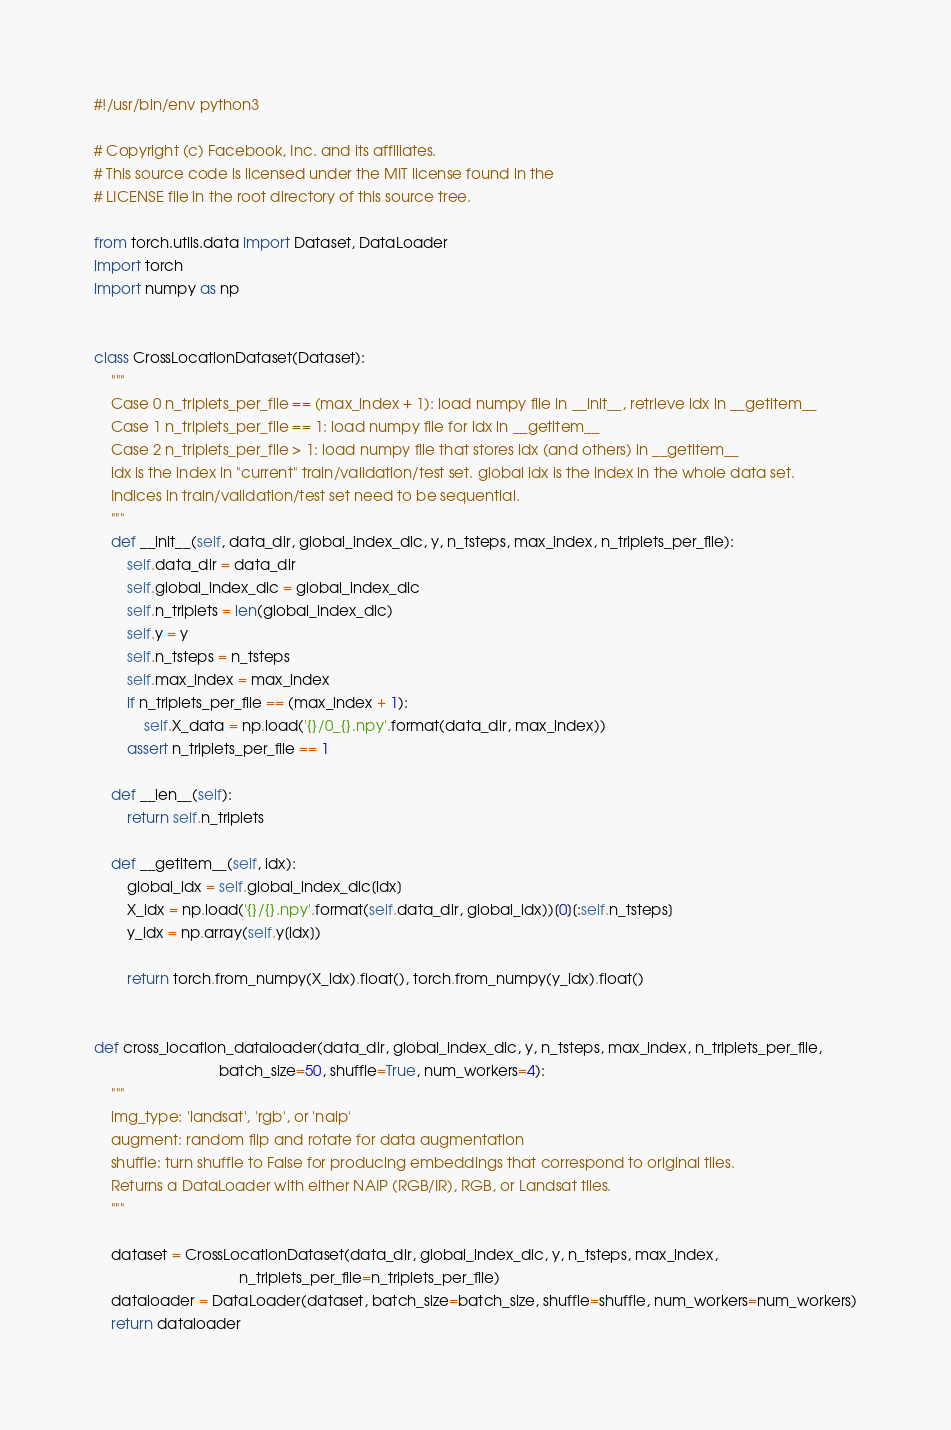Convert code to text. <code><loc_0><loc_0><loc_500><loc_500><_Python_>#!/usr/bin/env python3

# Copyright (c) Facebook, Inc. and its affiliates.
# This source code is licensed under the MIT license found in the
# LICENSE file in the root directory of this source tree.

from torch.utils.data import Dataset, DataLoader
import torch
import numpy as np


class CrossLocationDataset(Dataset):
    """
    Case 0 n_triplets_per_file == (max_index + 1): load numpy file in __init__, retrieve idx in __getitem__
    Case 1 n_triplets_per_file == 1: load numpy file for idx in __getitem__
    Case 2 n_triplets_per_file > 1: load numpy file that stores idx (and others) in __getitem__
    idx is the index in "current" train/validation/test set. global idx is the index in the whole data set.
    Indices in train/validation/test set need to be sequential.
    """
    def __init__(self, data_dir, global_index_dic, y, n_tsteps, max_index, n_triplets_per_file):
        self.data_dir = data_dir
        self.global_index_dic = global_index_dic
        self.n_triplets = len(global_index_dic)
        self.y = y
        self.n_tsteps = n_tsteps
        self.max_index = max_index
        if n_triplets_per_file == (max_index + 1):
            self.X_data = np.load('{}/0_{}.npy'.format(data_dir, max_index))
        assert n_triplets_per_file == 1

    def __len__(self):
        return self.n_triplets

    def __getitem__(self, idx):
        global_idx = self.global_index_dic[idx]
        X_idx = np.load('{}/{}.npy'.format(self.data_dir, global_idx))[0][:self.n_tsteps]
        y_idx = np.array(self.y[idx])

        return torch.from_numpy(X_idx).float(), torch.from_numpy(y_idx).float()


def cross_location_dataloader(data_dir, global_index_dic, y, n_tsteps, max_index, n_triplets_per_file,
                              batch_size=50, shuffle=True, num_workers=4):
    """
    img_type: 'landsat', 'rgb', or 'naip'
    augment: random flip and rotate for data augmentation
    shuffle: turn shuffle to False for producing embeddings that correspond to original tiles.
    Returns a DataLoader with either NAIP (RGB/IR), RGB, or Landsat tiles.
    """

    dataset = CrossLocationDataset(data_dir, global_index_dic, y, n_tsteps, max_index,
                                   n_triplets_per_file=n_triplets_per_file)
    dataloader = DataLoader(dataset, batch_size=batch_size, shuffle=shuffle, num_workers=num_workers)
    return dataloader
</code> 